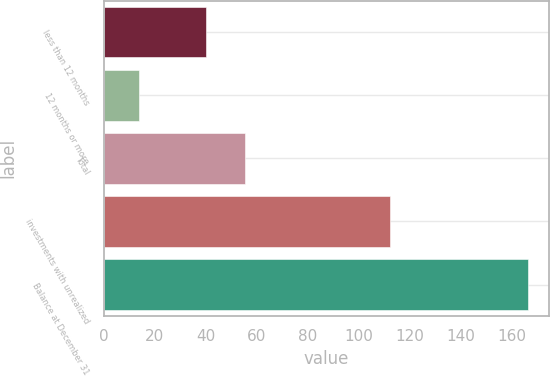Convert chart to OTSL. <chart><loc_0><loc_0><loc_500><loc_500><bar_chart><fcel>less than 12 months<fcel>12 months or more<fcel>Total<fcel>investments with unrealized<fcel>Balance at December 31<nl><fcel>40.1<fcel>13.8<fcel>55.32<fcel>112.1<fcel>166<nl></chart> 